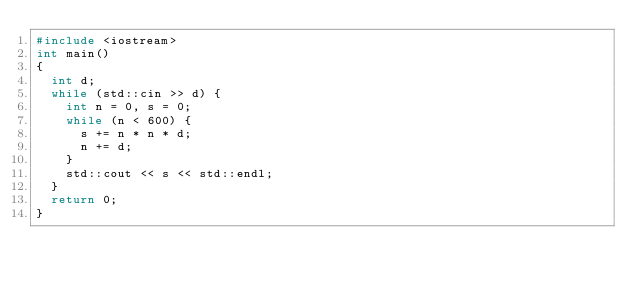Convert code to text. <code><loc_0><loc_0><loc_500><loc_500><_C++_>#include <iostream>
int main()
{
  int d;
  while (std::cin >> d) {
    int n = 0, s = 0;
    while (n < 600) {
      s += n * n * d;
      n += d;
    }
    std::cout << s << std::endl;
  }
  return 0;
}</code> 